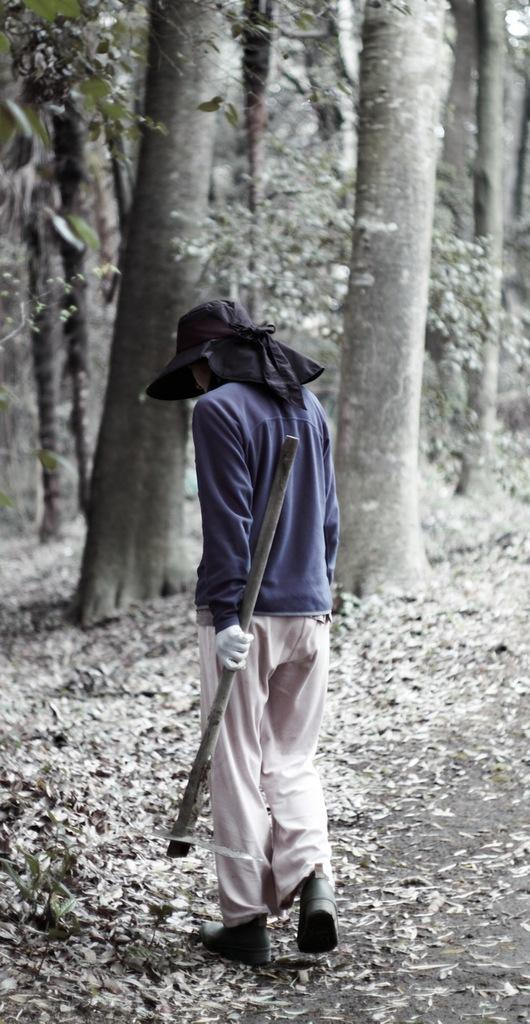What is present in the image? There is a person in the image. What is the person holding in the image? The person is holding an object. What type of natural environment can be seen in the image? There are trees in the image. What is visible on the ground in the image? There are leaves on the ground in the image. How many boats can be seen sailing in the image? There are no boats present in the image. What type of toys can be seen scattered on the ground in the image? There are no toys present in the image. 